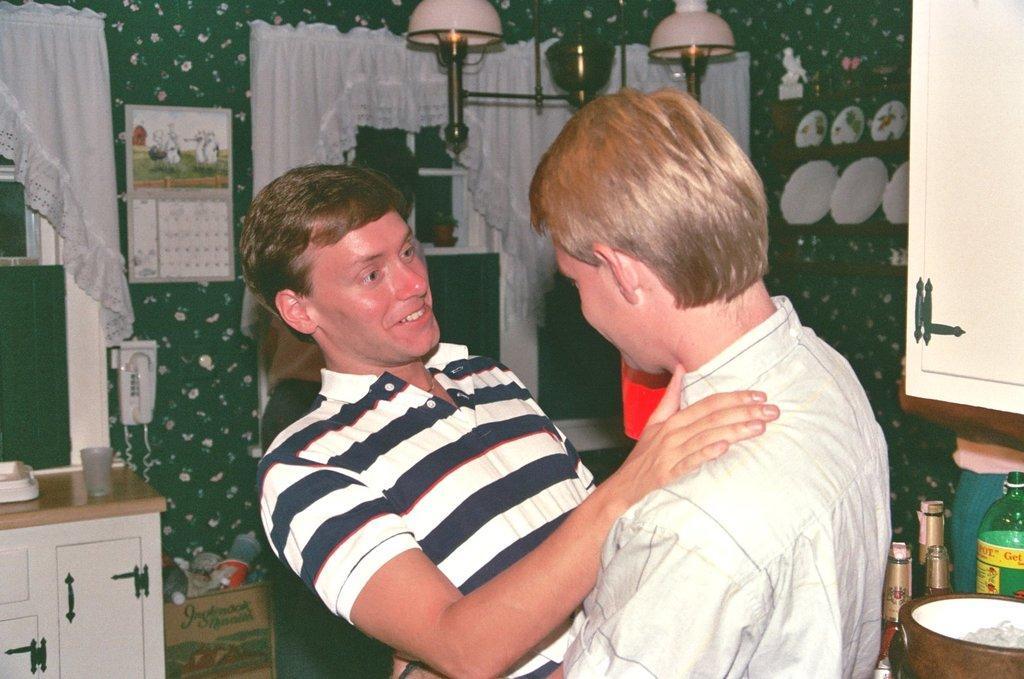Could you give a brief overview of what you see in this image? In front of the image there are two men standing. On the right side of the image there are bottles and some other things. Above them there is a cupboard. Beside that cupboard there are racks with plates and some other things. On the left side of the image there is a table. On the tables there are few things. Behind the table on the wall there are windows with curtains. Beside the window on the wall there is a telephone and a curtain. In front of the wall there is a cardboard box with few things in it. 